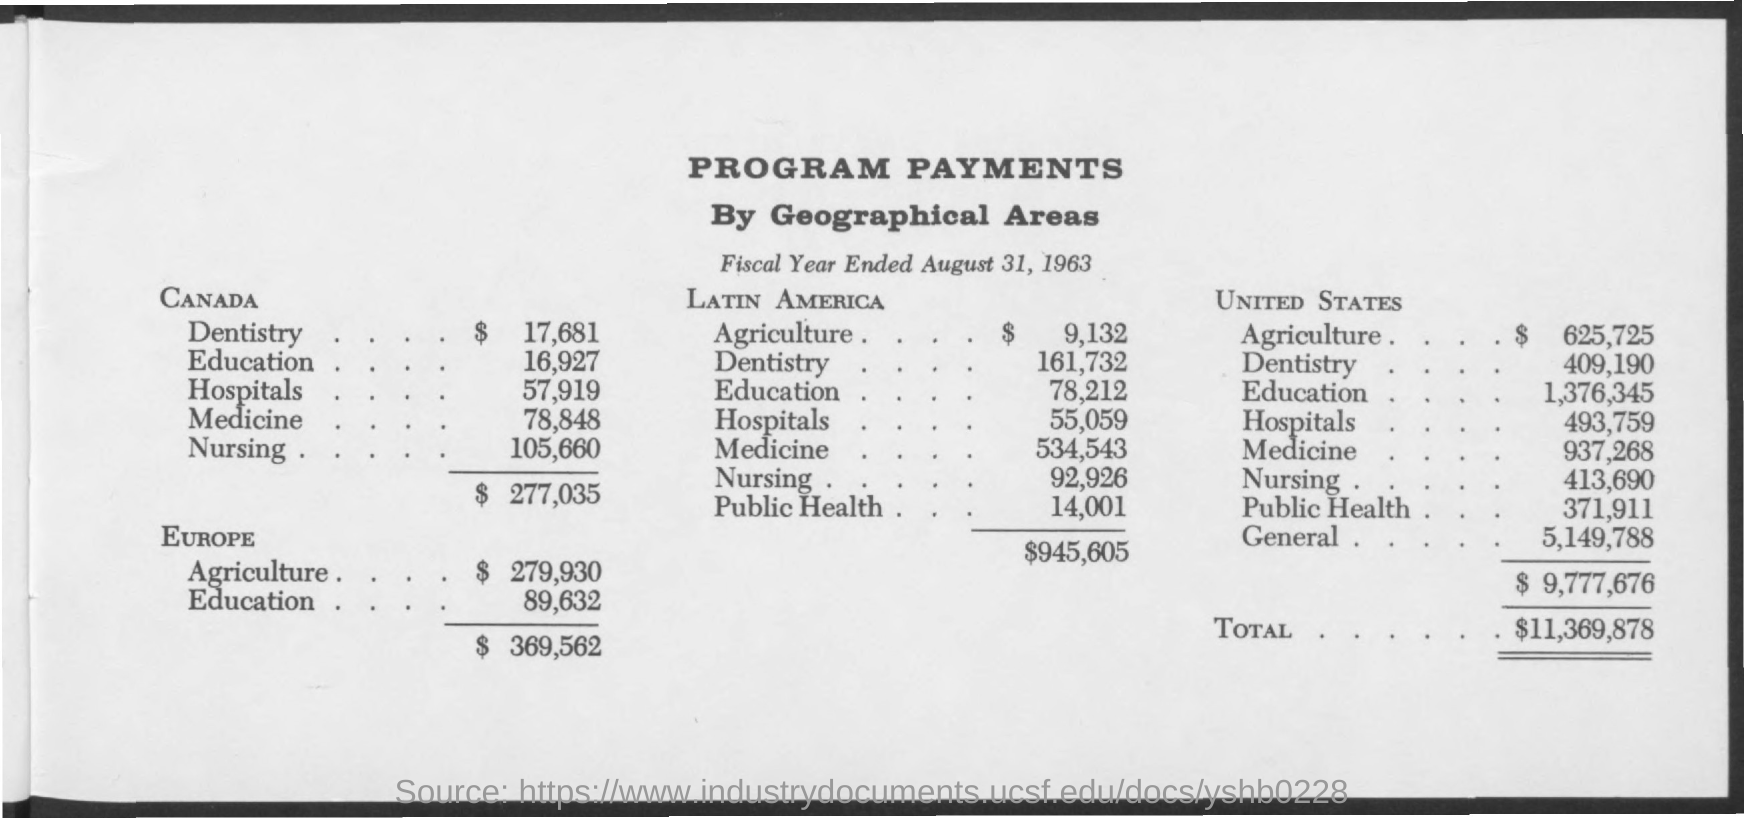What is the first title in the document?
Provide a short and direct response. Program Payments. What is the date mentioned in the document?
Make the answer very short. August 31, 1963. 